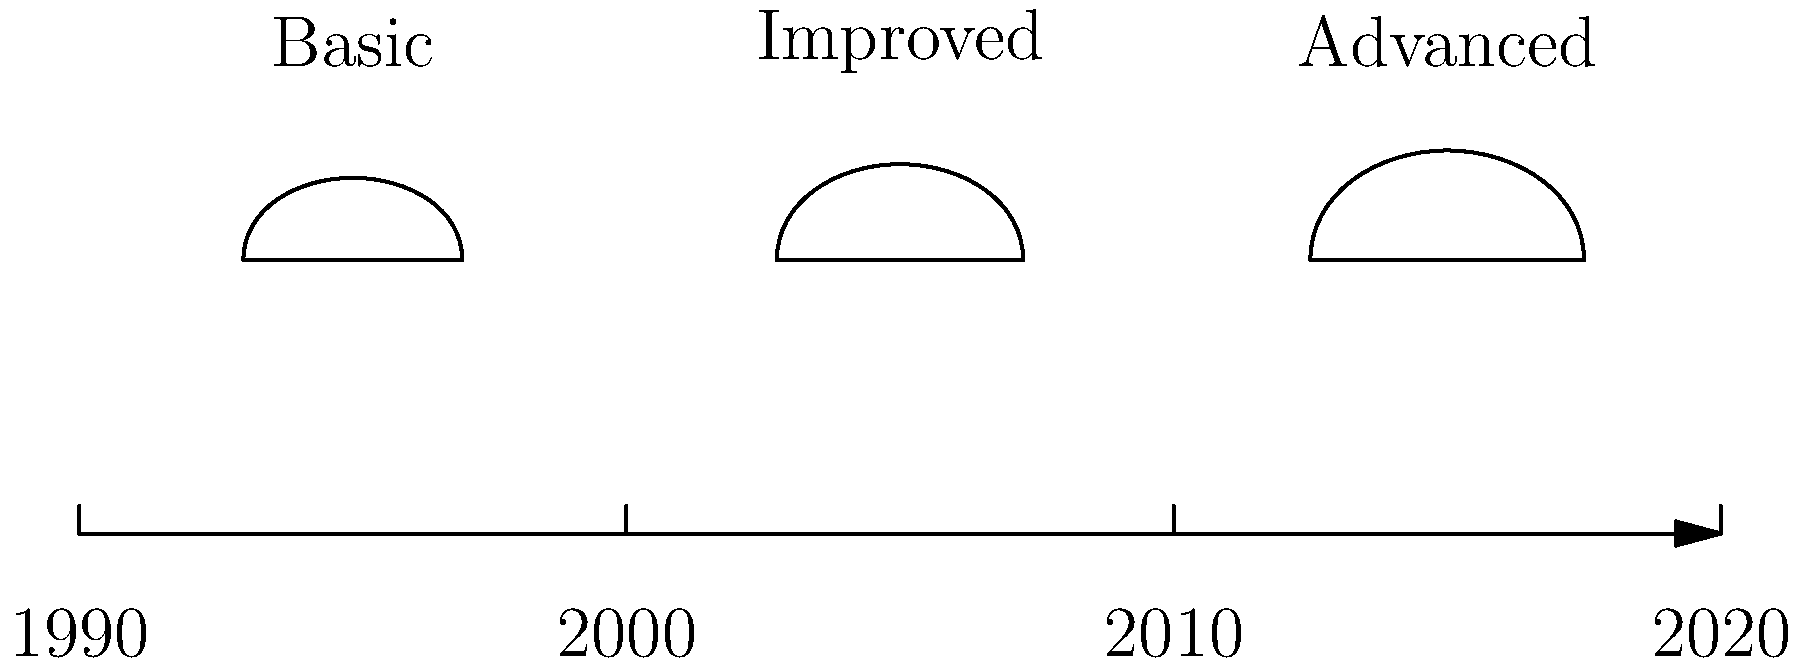Based on the timeline graphic showing the evolution of football helmet designs from the 90s to today, which decade saw the most significant increase in helmet size and curvature? To answer this question, we need to analyze the changes in helmet design over the decades shown in the timeline:

1. 1990s (leftmost helmet):
   - Smallest overall size
   - Basic shape with minimal curvature

2. 2000s (middle helmet):
   - Slightly larger than the 90s design
   - Moderately increased curvature

3. 2010s-2020s (rightmost helmet):
   - Largest overall size
   - Most pronounced curvature

Comparing the changes:
- From 1990s to 2000s: Modest increase in size and curvature
- From 2000s to 2010s-2020s: More significant increase in both size and curvature

The most notable change occurs between the 2000s and 2010s-2020s designs, indicating that the decade from 2000 to 2010 saw the most significant increase in helmet size and curvature.
Answer: 2000-2010 